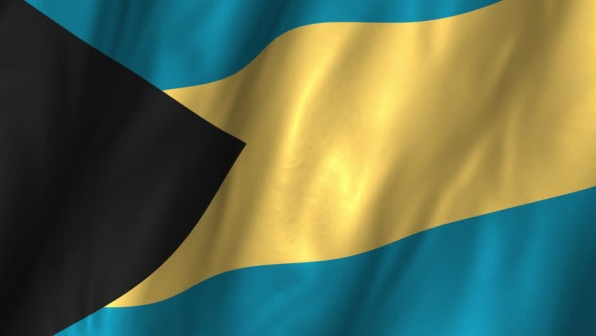Imagine if the flag could talk. What kind of stories would it share about its country? If the flag could talk, it might share stories of the vibrant and resilient people who populate the Bahamas. It would speak of the joyous Junkanoo festivals, where the streets come alive with music, dance, and colorful costumes. The flag would tell tales of the breathtaking beaches and turquoise waters that attract visitors from around the world. It would recount the history of the nation’s struggle for independence and the triumph of its people to emerge as a proud and unified country. In its flowing movements, the flag would embody the spirit of the island’s culture, the warmth of its hospitality, and the unyielding determination of its citizens to build a prosperous future. 